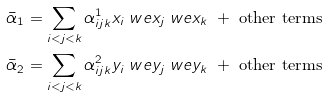Convert formula to latex. <formula><loc_0><loc_0><loc_500><loc_500>\bar { \alpha } _ { 1 } & = \sum _ { i < j < k } \alpha ^ { 1 } _ { i j k } x _ { i } \ w e x _ { j } \ w e x _ { k } \ + \text { other terms} \\ \bar { \alpha } _ { 2 } & = \sum _ { i < j < k } \alpha ^ { 2 } _ { i j k } y _ { i } \ w e y _ { j } \ w e y _ { k } \ + \text { other terms}</formula> 